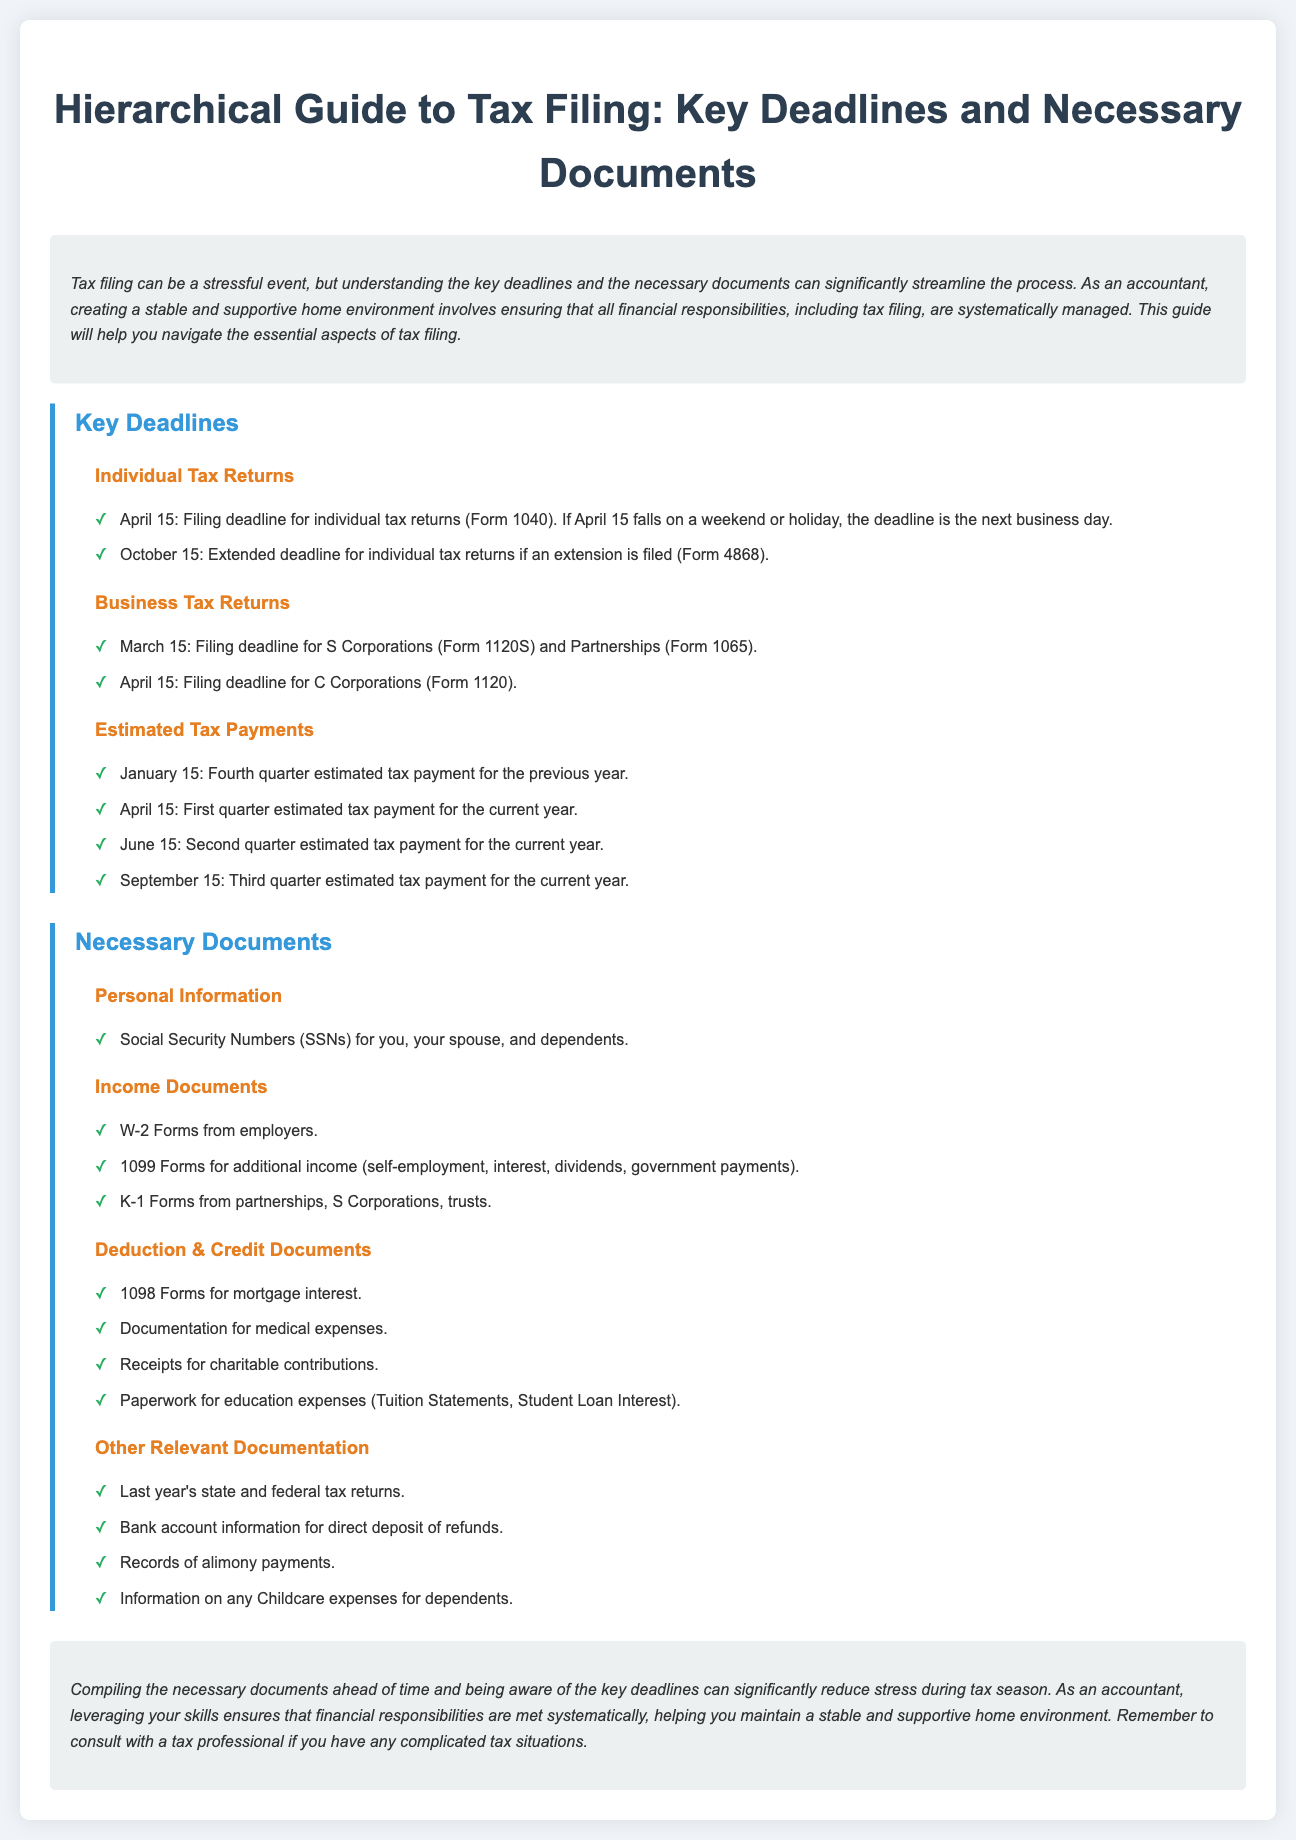What is the deadline for individual tax returns? The deadline is traditionally April 15, but it may change if it falls on a weekend or holiday.
Answer: April 15 When is the extended deadline for individual tax returns? If an extension is filed, the extended deadline is October 15 for individual tax returns.
Answer: October 15 Which form is used for S Corporations? The specific form for S Corporations is Form 1120S.
Answer: Form 1120S What document is required for mortgage interest deductions? The required document for mortgage interest deductions is a 1098 Form.
Answer: 1098 Form How many estimated tax payments are due each year? There are four estimated tax payments due each year.
Answer: Four What is included in the Necessary Documents section? It includes Personal Information, Income Documents, Deduction & Credit Documents, and Other Relevant Documentation.
Answer: Necessary Documents section What is one type of income document needed for filing taxes? One type of income document needed is the W-2 Form.
Answer: W-2 Form When is the first quarter estimated tax payment due? The first quarter estimated tax payment is due on April 15.
Answer: April 15 What does compiling necessary documents ahead of time help with? It helps significantly reduce stress during tax season.
Answer: Reduce stress 